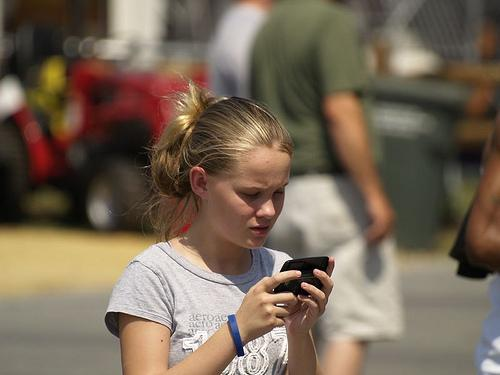What phone feature is she using?

Choices:
A) flip
B) slide
C) open
D) zoom slide 